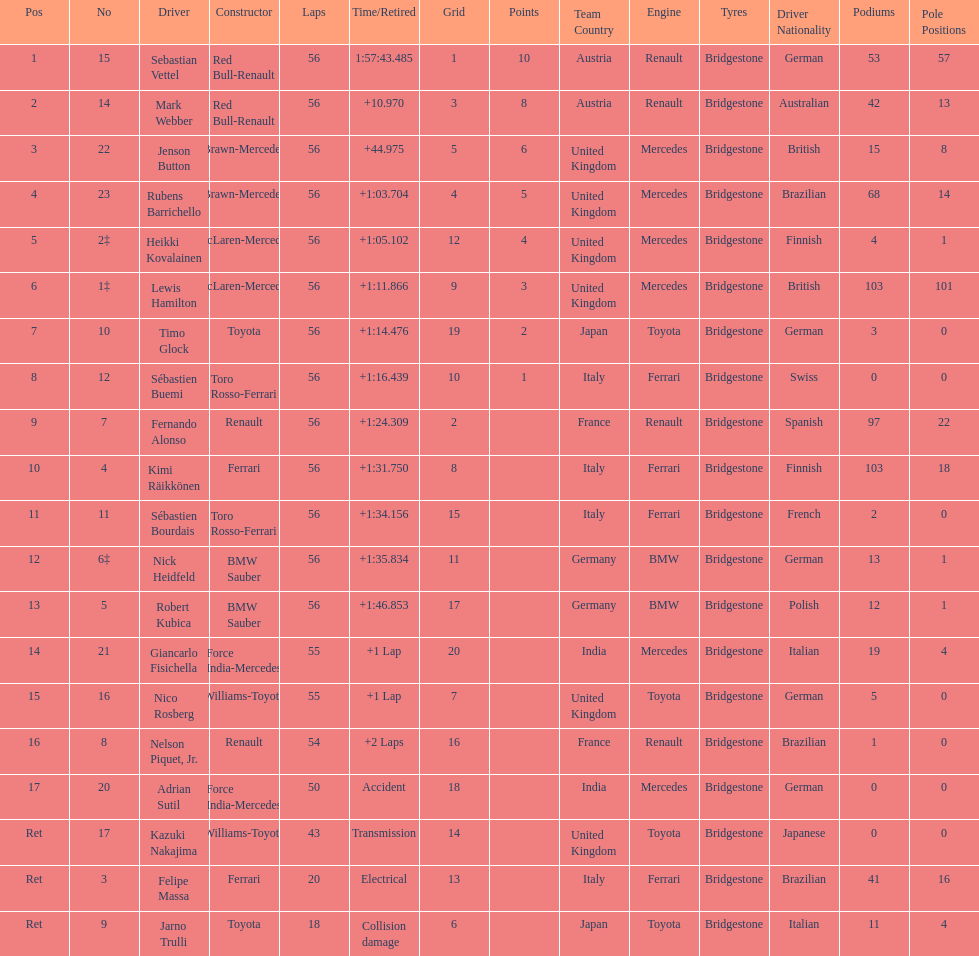What is the name of a driver that ferrari was not a constructor for? Sebastian Vettel. 